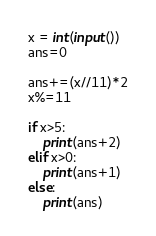<code> <loc_0><loc_0><loc_500><loc_500><_Python_>x = int(input())
ans=0

ans+=(x//11)*2
x%=11

if x>5:
    print(ans+2)
elif x>0:
    print(ans+1)
else:
    print(ans)</code> 